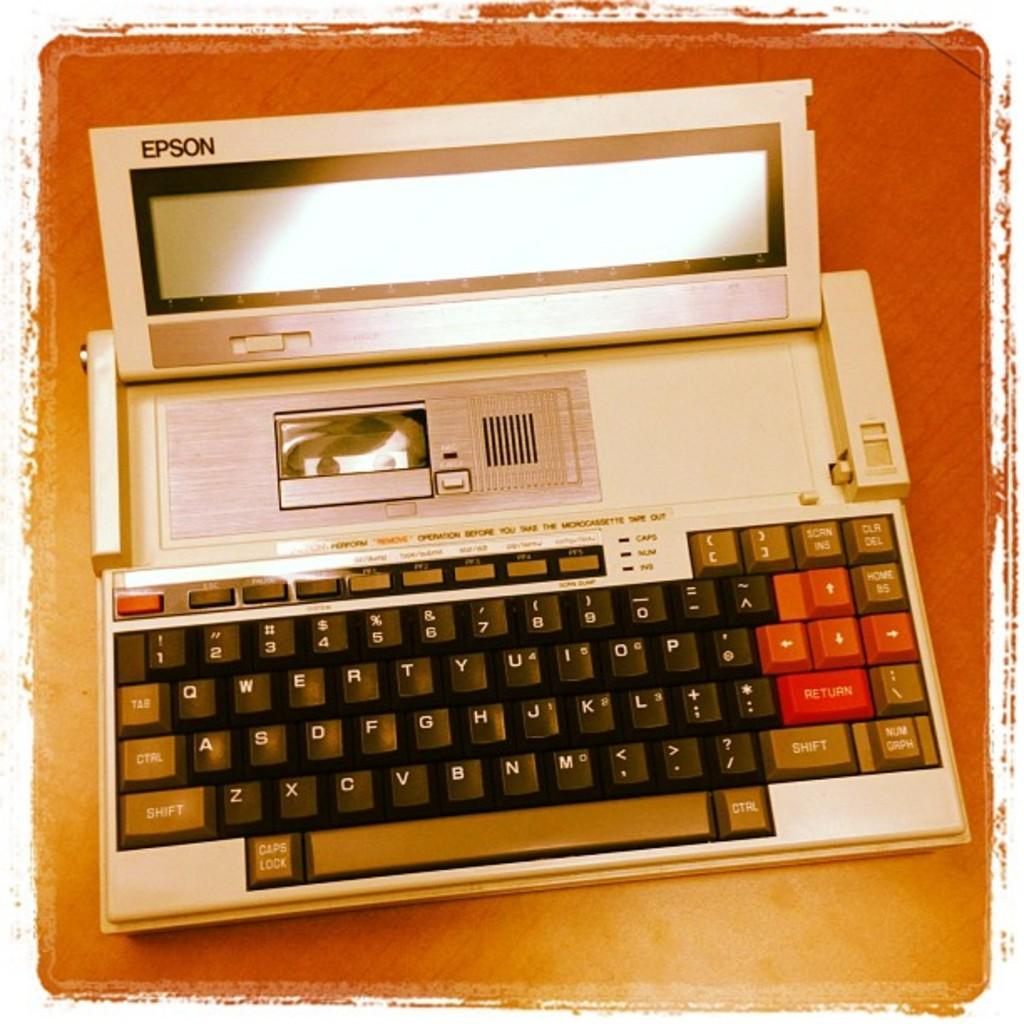<image>
Render a clear and concise summary of the photo. A white Epson electronic typewriter with a black keyboard sitting on a table 